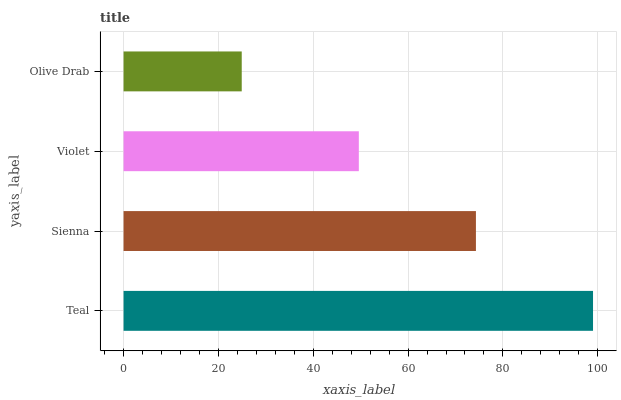Is Olive Drab the minimum?
Answer yes or no. Yes. Is Teal the maximum?
Answer yes or no. Yes. Is Sienna the minimum?
Answer yes or no. No. Is Sienna the maximum?
Answer yes or no. No. Is Teal greater than Sienna?
Answer yes or no. Yes. Is Sienna less than Teal?
Answer yes or no. Yes. Is Sienna greater than Teal?
Answer yes or no. No. Is Teal less than Sienna?
Answer yes or no. No. Is Sienna the high median?
Answer yes or no. Yes. Is Violet the low median?
Answer yes or no. Yes. Is Violet the high median?
Answer yes or no. No. Is Sienna the low median?
Answer yes or no. No. 